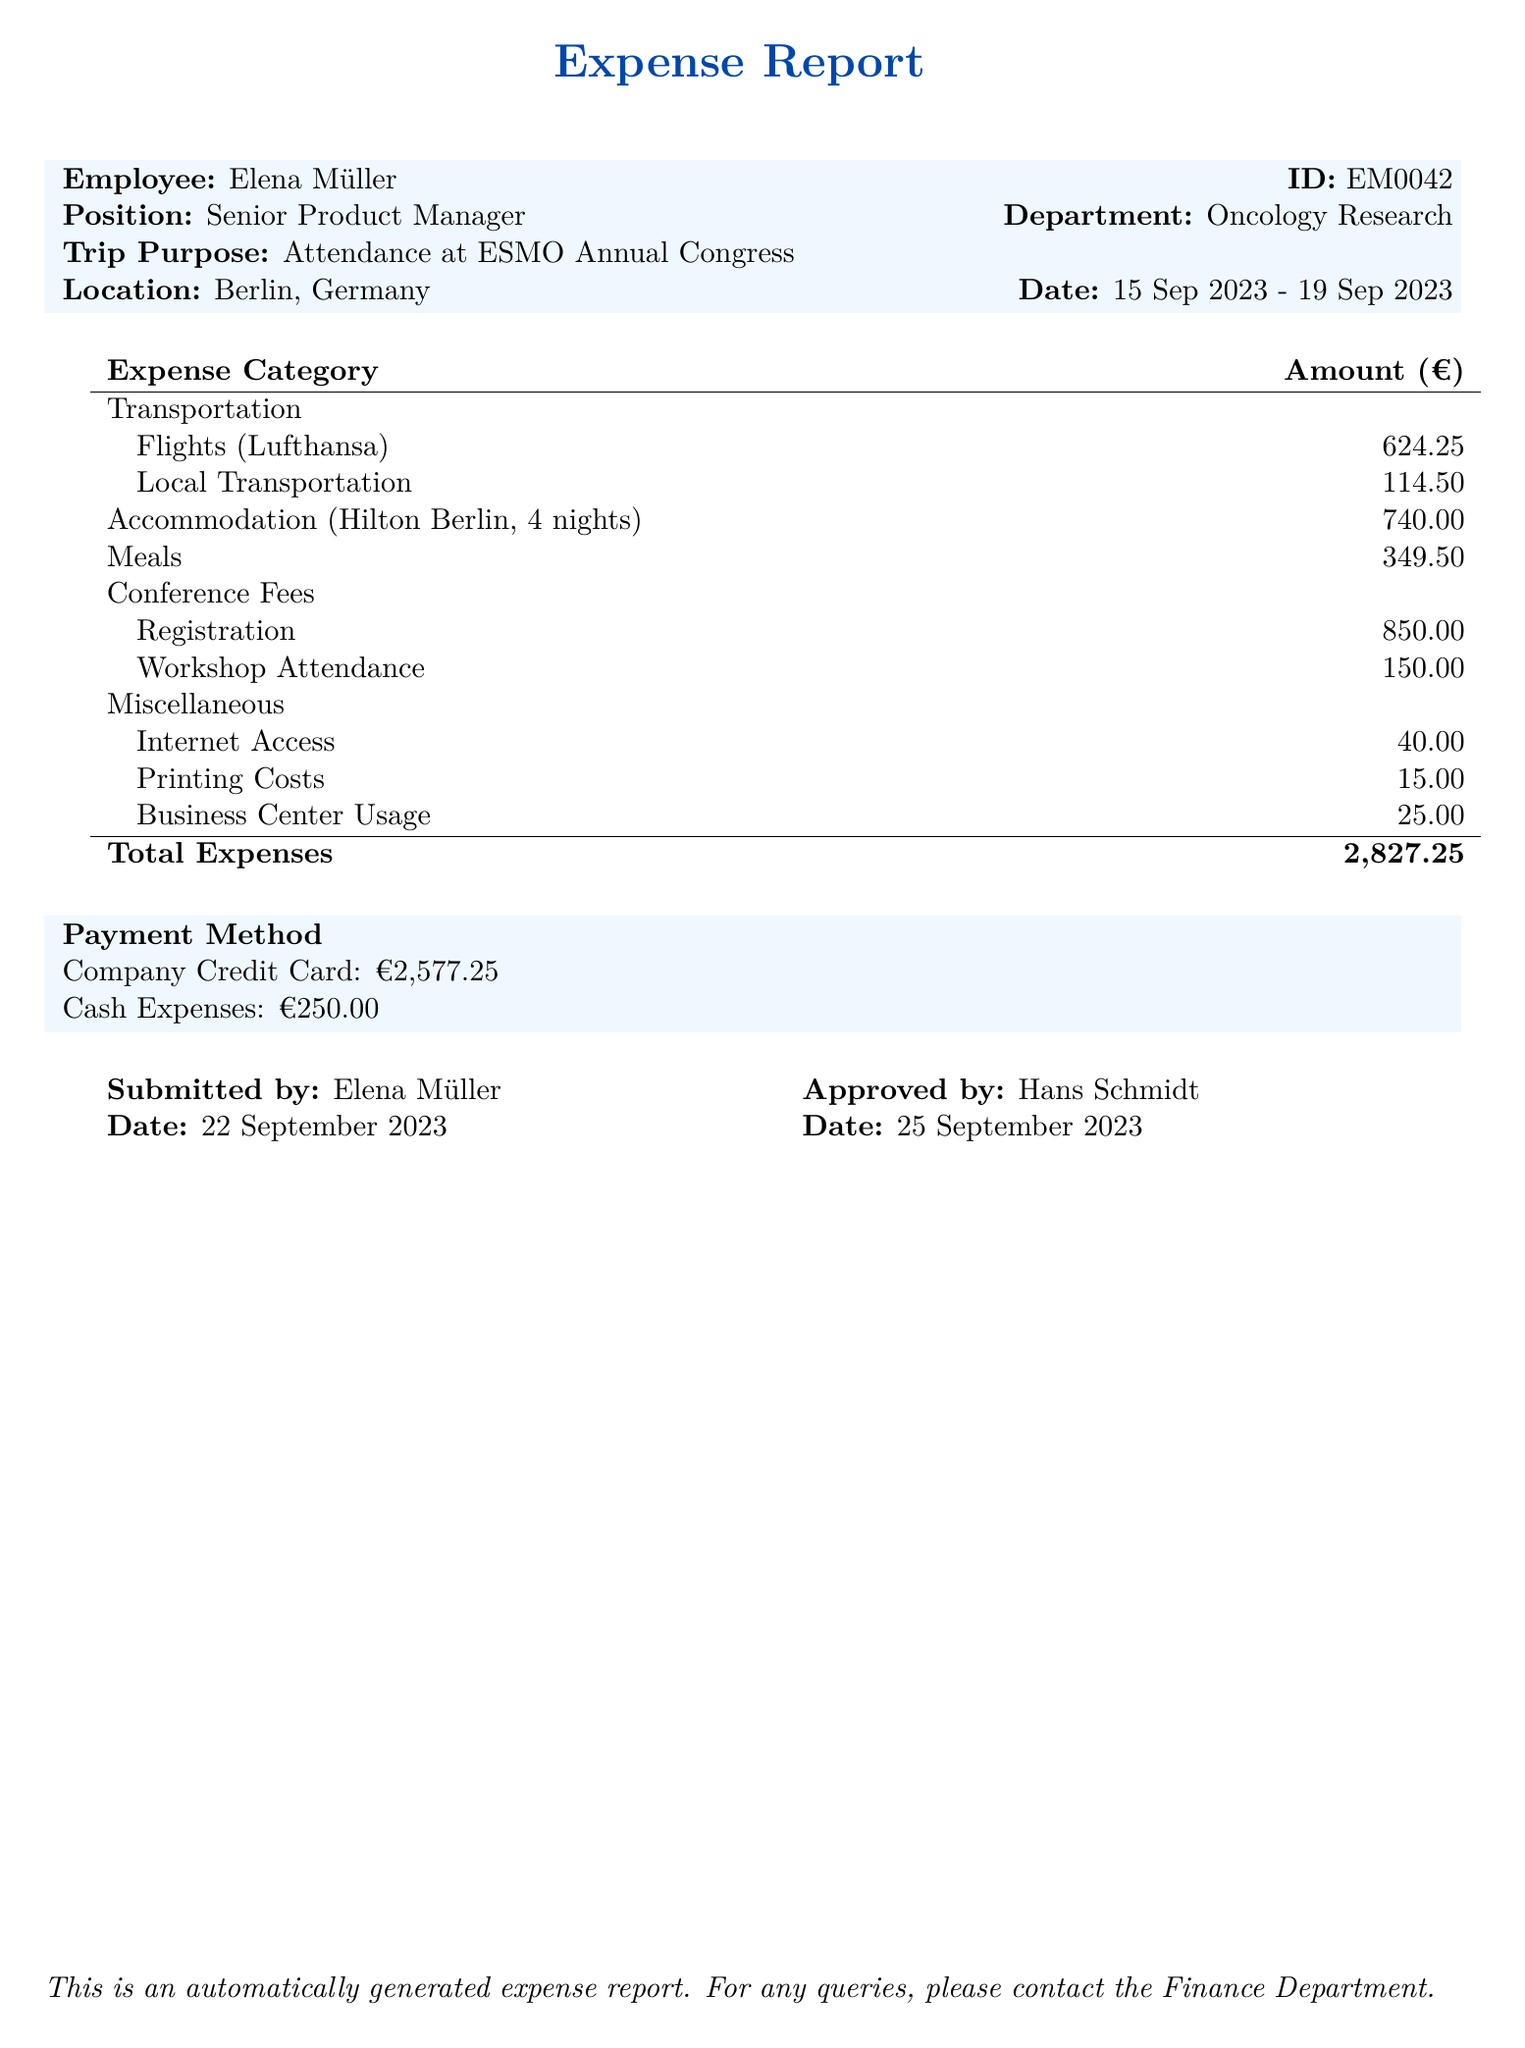what is the name of the employee? The name of the employee is provided in the employee_info section of the document.
Answer: Elena Müller what is the total accommodation cost? The total accommodation cost is presented under the accommodation section.
Answer: 740.00 how many nights did the employee stay at the hotel? The number of nights is given in the accommodation details in the document.
Answer: 4 what is the cost of the return flight? The cost of the return flight is listed under the transportation section.
Answer: 298.75 what is the total amount claimed for meals? The total amount for meals is calculated from the meals section of the document.
Answer: 349.50 how much was spent on local transportation? The local transportation costs are detailed under the transportation section.
Answer: 114.50 what is the date of submission of the expense report? The date of submission is mentioned in the approvals section of the document.
Answer: 22 September 2023 what are the total expenses incurred? The total expenses are summarized at the end of the expense report.
Answer: 2827.25 how much was paid using cash expenses? The cash expenses are detailed in the payment method section.
Answer: 250.00 